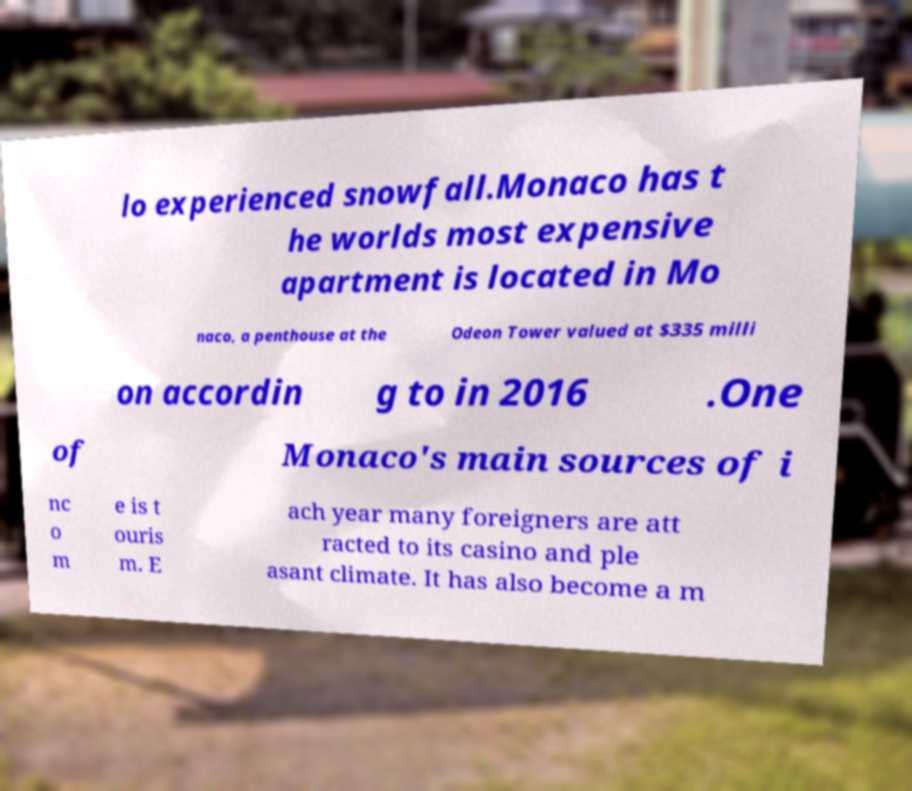There's text embedded in this image that I need extracted. Can you transcribe it verbatim? lo experienced snowfall.Monaco has t he worlds most expensive apartment is located in Mo naco, a penthouse at the Odeon Tower valued at $335 milli on accordin g to in 2016 .One of Monaco's main sources of i nc o m e is t ouris m. E ach year many foreigners are att racted to its casino and ple asant climate. It has also become a m 